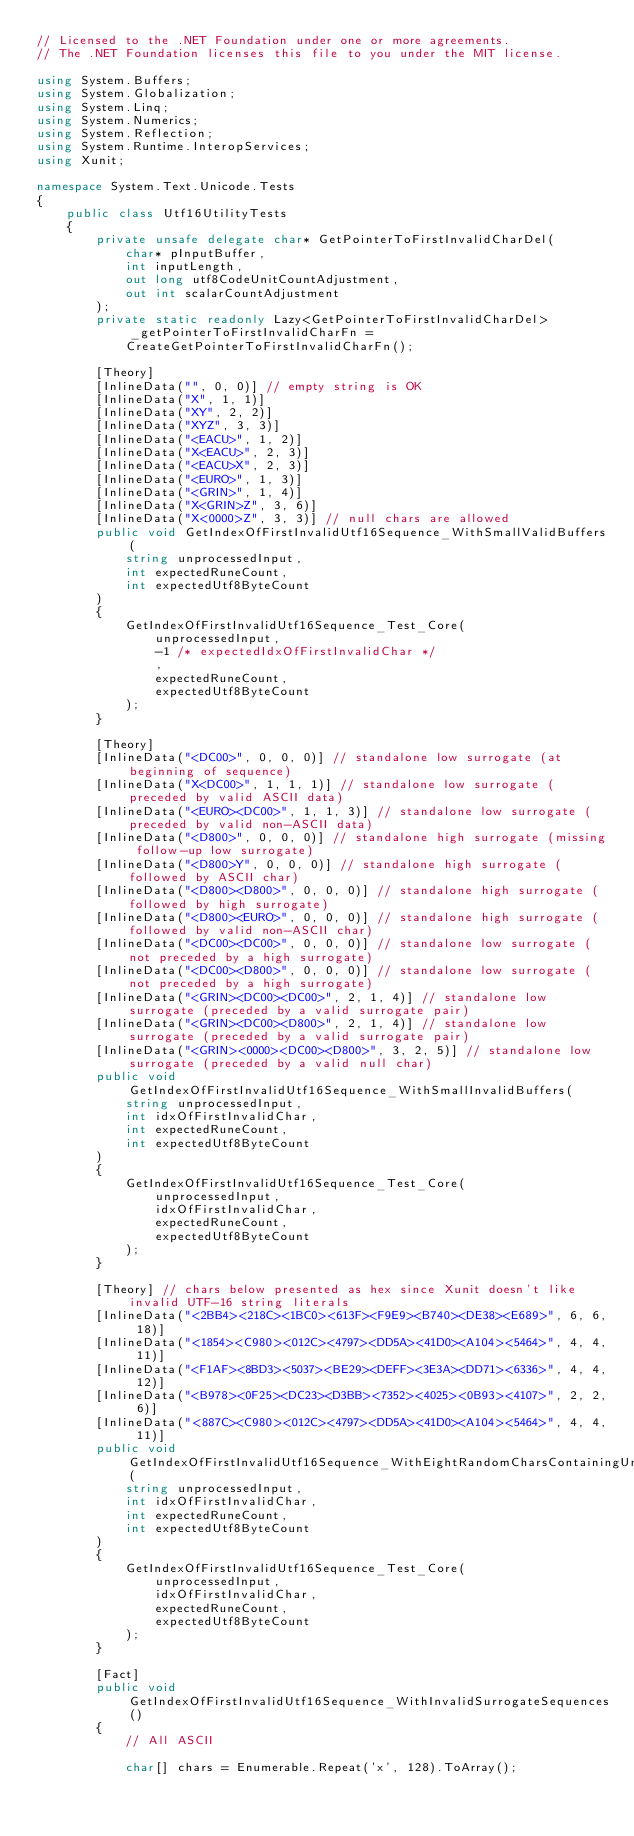<code> <loc_0><loc_0><loc_500><loc_500><_C#_>// Licensed to the .NET Foundation under one or more agreements.
// The .NET Foundation licenses this file to you under the MIT license.

using System.Buffers;
using System.Globalization;
using System.Linq;
using System.Numerics;
using System.Reflection;
using System.Runtime.InteropServices;
using Xunit;

namespace System.Text.Unicode.Tests
{
    public class Utf16UtilityTests
    {
        private unsafe delegate char* GetPointerToFirstInvalidCharDel(
            char* pInputBuffer,
            int inputLength,
            out long utf8CodeUnitCountAdjustment,
            out int scalarCountAdjustment
        );
        private static readonly Lazy<GetPointerToFirstInvalidCharDel> _getPointerToFirstInvalidCharFn =
            CreateGetPointerToFirstInvalidCharFn();

        [Theory]
        [InlineData("", 0, 0)] // empty string is OK
        [InlineData("X", 1, 1)]
        [InlineData("XY", 2, 2)]
        [InlineData("XYZ", 3, 3)]
        [InlineData("<EACU>", 1, 2)]
        [InlineData("X<EACU>", 2, 3)]
        [InlineData("<EACU>X", 2, 3)]
        [InlineData("<EURO>", 1, 3)]
        [InlineData("<GRIN>", 1, 4)]
        [InlineData("X<GRIN>Z", 3, 6)]
        [InlineData("X<0000>Z", 3, 3)] // null chars are allowed
        public void GetIndexOfFirstInvalidUtf16Sequence_WithSmallValidBuffers(
            string unprocessedInput,
            int expectedRuneCount,
            int expectedUtf8ByteCount
        )
        {
            GetIndexOfFirstInvalidUtf16Sequence_Test_Core(
                unprocessedInput,
                -1 /* expectedIdxOfFirstInvalidChar */
                ,
                expectedRuneCount,
                expectedUtf8ByteCount
            );
        }

        [Theory]
        [InlineData("<DC00>", 0, 0, 0)] // standalone low surrogate (at beginning of sequence)
        [InlineData("X<DC00>", 1, 1, 1)] // standalone low surrogate (preceded by valid ASCII data)
        [InlineData("<EURO><DC00>", 1, 1, 3)] // standalone low surrogate (preceded by valid non-ASCII data)
        [InlineData("<D800>", 0, 0, 0)] // standalone high surrogate (missing follow-up low surrogate)
        [InlineData("<D800>Y", 0, 0, 0)] // standalone high surrogate (followed by ASCII char)
        [InlineData("<D800><D800>", 0, 0, 0)] // standalone high surrogate (followed by high surrogate)
        [InlineData("<D800><EURO>", 0, 0, 0)] // standalone high surrogate (followed by valid non-ASCII char)
        [InlineData("<DC00><DC00>", 0, 0, 0)] // standalone low surrogate (not preceded by a high surrogate)
        [InlineData("<DC00><D800>", 0, 0, 0)] // standalone low surrogate (not preceded by a high surrogate)
        [InlineData("<GRIN><DC00><DC00>", 2, 1, 4)] // standalone low surrogate (preceded by a valid surrogate pair)
        [InlineData("<GRIN><DC00><D800>", 2, 1, 4)] // standalone low surrogate (preceded by a valid surrogate pair)
        [InlineData("<GRIN><0000><DC00><D800>", 3, 2, 5)] // standalone low surrogate (preceded by a valid null char)
        public void GetIndexOfFirstInvalidUtf16Sequence_WithSmallInvalidBuffers(
            string unprocessedInput,
            int idxOfFirstInvalidChar,
            int expectedRuneCount,
            int expectedUtf8ByteCount
        )
        {
            GetIndexOfFirstInvalidUtf16Sequence_Test_Core(
                unprocessedInput,
                idxOfFirstInvalidChar,
                expectedRuneCount,
                expectedUtf8ByteCount
            );
        }

        [Theory] // chars below presented as hex since Xunit doesn't like invalid UTF-16 string literals
        [InlineData("<2BB4><218C><1BC0><613F><F9E9><B740><DE38><E689>", 6, 6, 18)]
        [InlineData("<1854><C980><012C><4797><DD5A><41D0><A104><5464>", 4, 4, 11)]
        [InlineData("<F1AF><8BD3><5037><BE29><DEFF><3E3A><DD71><6336>", 4, 4, 12)]
        [InlineData("<B978><0F25><DC23><D3BB><7352><4025><0B93><4107>", 2, 2, 6)]
        [InlineData("<887C><C980><012C><4797><DD5A><41D0><A104><5464>", 4, 4, 11)]
        public void GetIndexOfFirstInvalidUtf16Sequence_WithEightRandomCharsContainingUnpairedSurrogates(
            string unprocessedInput,
            int idxOfFirstInvalidChar,
            int expectedRuneCount,
            int expectedUtf8ByteCount
        )
        {
            GetIndexOfFirstInvalidUtf16Sequence_Test_Core(
                unprocessedInput,
                idxOfFirstInvalidChar,
                expectedRuneCount,
                expectedUtf8ByteCount
            );
        }

        [Fact]
        public void GetIndexOfFirstInvalidUtf16Sequence_WithInvalidSurrogateSequences()
        {
            // All ASCII

            char[] chars = Enumerable.Repeat('x', 128).ToArray();</code> 